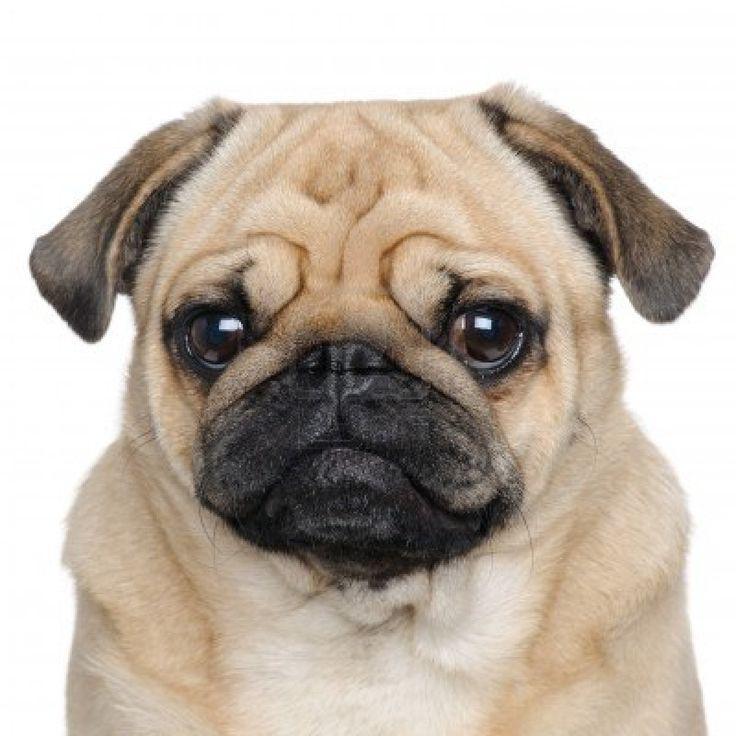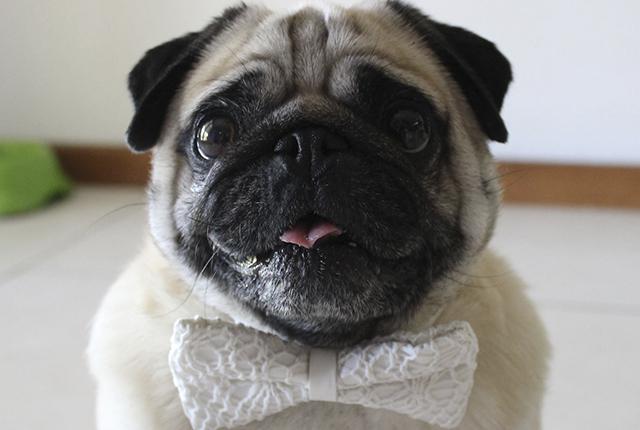The first image is the image on the left, the second image is the image on the right. Examine the images to the left and right. Is the description "Whites of the eyes are very visible on the dog on the left." accurate? Answer yes or no. No. 